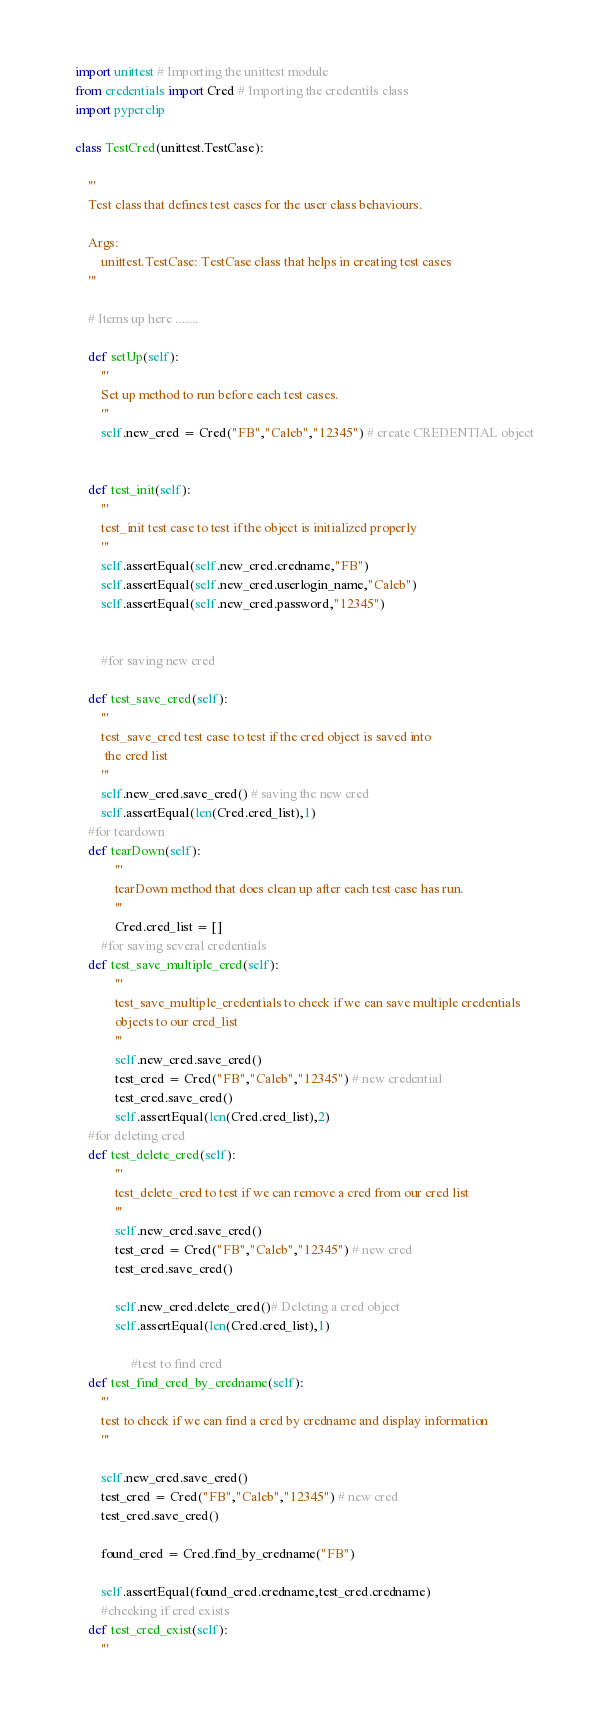<code> <loc_0><loc_0><loc_500><loc_500><_Python_>import unittest # Importing the unittest module
from credentials import Cred # Importing the credentils class
import pyperclip

class TestCred(unittest.TestCase):

    '''
    Test class that defines test cases for the user class behaviours.

    Args:
        unittest.TestCase: TestCase class that helps in creating test cases
    '''

    # Items up here .......

    def setUp(self):
        '''
        Set up method to run before each test cases.
        '''
        self.new_cred = Cred("FB","Caleb","12345") # create CREDENTIAL object


    def test_init(self):
        '''
        test_init test case to test if the object is initialized properly
        '''
        self.assertEqual(self.new_cred.credname,"FB")
        self.assertEqual(self.new_cred.userlogin_name,"Caleb")
        self.assertEqual(self.new_cred.password,"12345")
       

        #for saving new cred

    def test_save_cred(self):
        '''
        test_save_cred test case to test if the cred object is saved into
         the cred list
        '''
        self.new_cred.save_cred() # saving the new cred
        self.assertEqual(len(Cred.cred_list),1)
    #for teardown
    def tearDown(self):
            '''
            tearDown method that does clean up after each test case has run.
            '''
            Cred.cred_list = []
        #for saving several credentials
    def test_save_multiple_cred(self):
            '''
            test_save_multiple_credentials to check if we can save multiple credentials
            objects to our cred_list
            '''
            self.new_cred.save_cred()
            test_cred = Cred("FB","Caleb","12345") # new credential
            test_cred.save_cred()
            self.assertEqual(len(Cred.cred_list),2)
    #for deleting cred
    def test_delete_cred(self):
            '''
            test_delete_cred to test if we can remove a cred from our cred list
            '''
            self.new_cred.save_cred()
            test_cred = Cred("FB","Caleb","12345") # new cred
            test_cred.save_cred()

            self.new_cred.delete_cred()# Deleting a cred object
            self.assertEqual(len(Cred.cred_list),1)

                 #test to find cred
    def test_find_cred_by_credname(self):
        '''
        test to check if we can find a cred by credname and display information
        '''

        self.new_cred.save_cred()
        test_cred = Cred("FB","Caleb","12345") # new cred
        test_cred.save_cred()

        found_cred = Cred.find_by_credname("FB")

        self.assertEqual(found_cred.credname,test_cred.credname)
        #checking if cred exists
    def test_cred_exist(self):
        '''</code> 